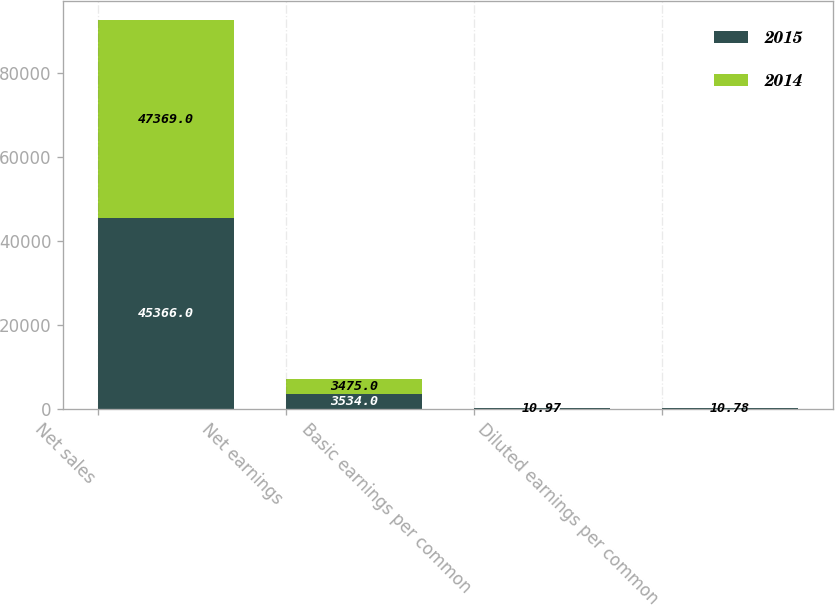<chart> <loc_0><loc_0><loc_500><loc_500><stacked_bar_chart><ecel><fcel>Net sales<fcel>Net earnings<fcel>Basic earnings per common<fcel>Diluted earnings per common<nl><fcel>2015<fcel>45366<fcel>3534<fcel>11.39<fcel>11.23<nl><fcel>2014<fcel>47369<fcel>3475<fcel>10.97<fcel>10.78<nl></chart> 